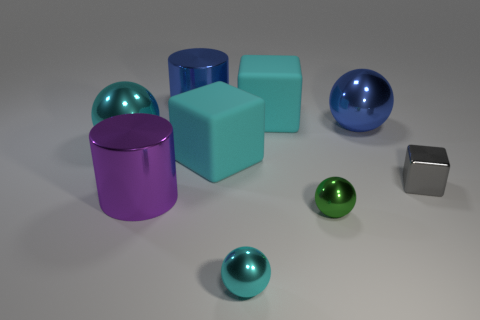Subtract 1 spheres. How many spheres are left? 3 Add 1 big gray metal balls. How many objects exist? 10 Subtract all cylinders. How many objects are left? 7 Subtract 1 purple cylinders. How many objects are left? 8 Subtract all big cyan metallic spheres. Subtract all blue metal spheres. How many objects are left? 7 Add 5 small gray things. How many small gray things are left? 6 Add 7 green metallic objects. How many green metallic objects exist? 8 